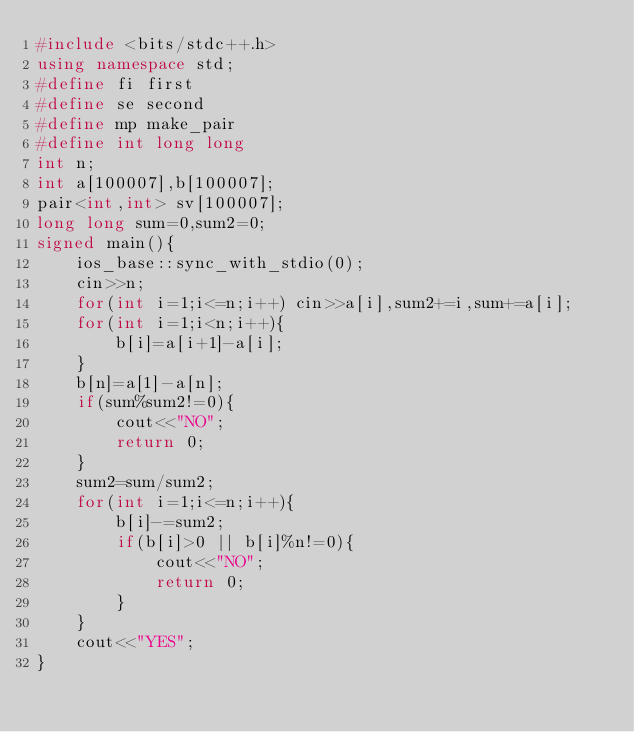Convert code to text. <code><loc_0><loc_0><loc_500><loc_500><_C++_>#include <bits/stdc++.h>
using namespace std;
#define fi first
#define se second
#define mp make_pair
#define int long long
int n;
int a[100007],b[100007];
pair<int,int> sv[100007];
long long sum=0,sum2=0;
signed main(){
	ios_base::sync_with_stdio(0);
	cin>>n;
	for(int i=1;i<=n;i++) cin>>a[i],sum2+=i,sum+=a[i];
	for(int i=1;i<n;i++){
		b[i]=a[i+1]-a[i];
	}
	b[n]=a[1]-a[n];
	if(sum%sum2!=0){
		cout<<"NO";
		return 0;
	}
	sum2=sum/sum2;
	for(int i=1;i<=n;i++){
		b[i]-=sum2;
		if(b[i]>0 || b[i]%n!=0){
			cout<<"NO";
			return 0;
		}
	}
	cout<<"YES";
}
</code> 